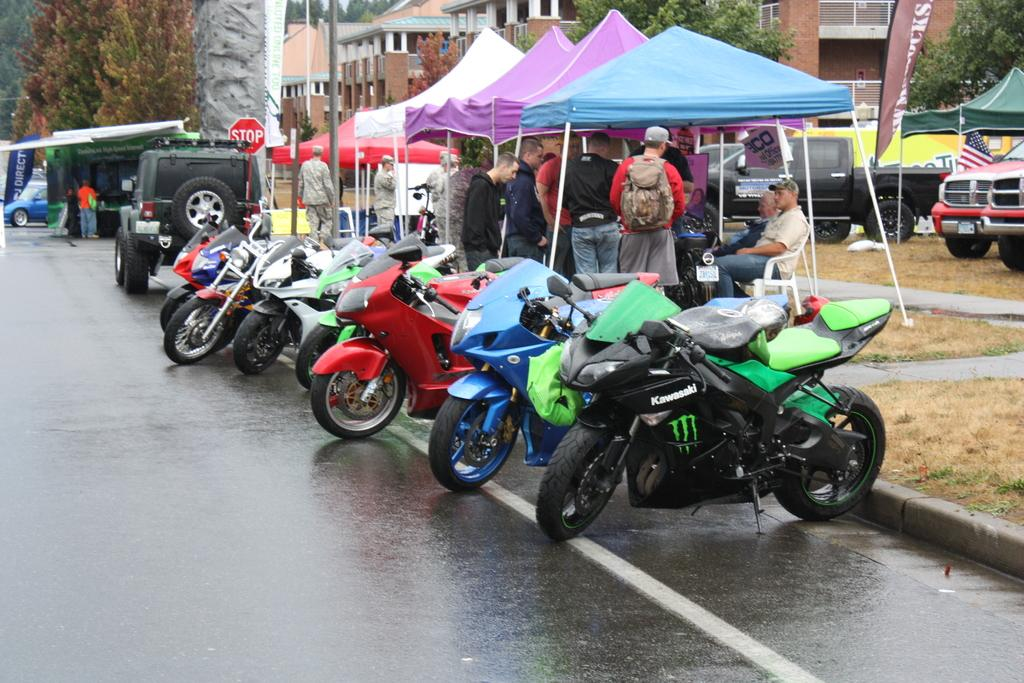What types of objects are present in the image? There are vehicles, persons, tents, buildings, and trees in the image. Can you describe the people in the image? The image contains persons, but their specific actions or characteristics are not mentioned in the facts. What structures can be seen in the image? There are tents and buildings in the image. What type of natural environment is visible in the image? Trees are visible in the image, indicating a natural environment. How does the island appear in the image? There is no island present in the image. What is the middle of the image showing? The facts provided do not specify any particular focus or subject in the middle of the image. 